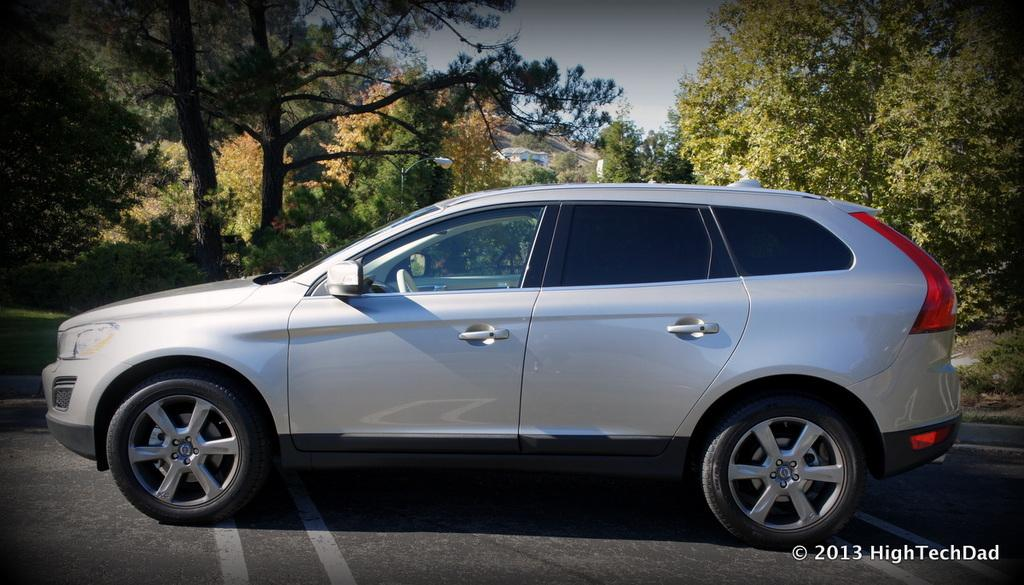What is on the road in the image? There is a vehicle on the road in the image. What can be seen behind the vehicle? There are trees behind the vehicle. What type of lighting is present in the image? There is a street light in the image. What structure is visible in the background of the image? There is a building in the background of the image. What is visible at the top of the image? The sky is visible in the background of the image. What type of stamp can be seen on the tree in the image? There is no stamp present on the tree in the image, as trees do not have stamps. 